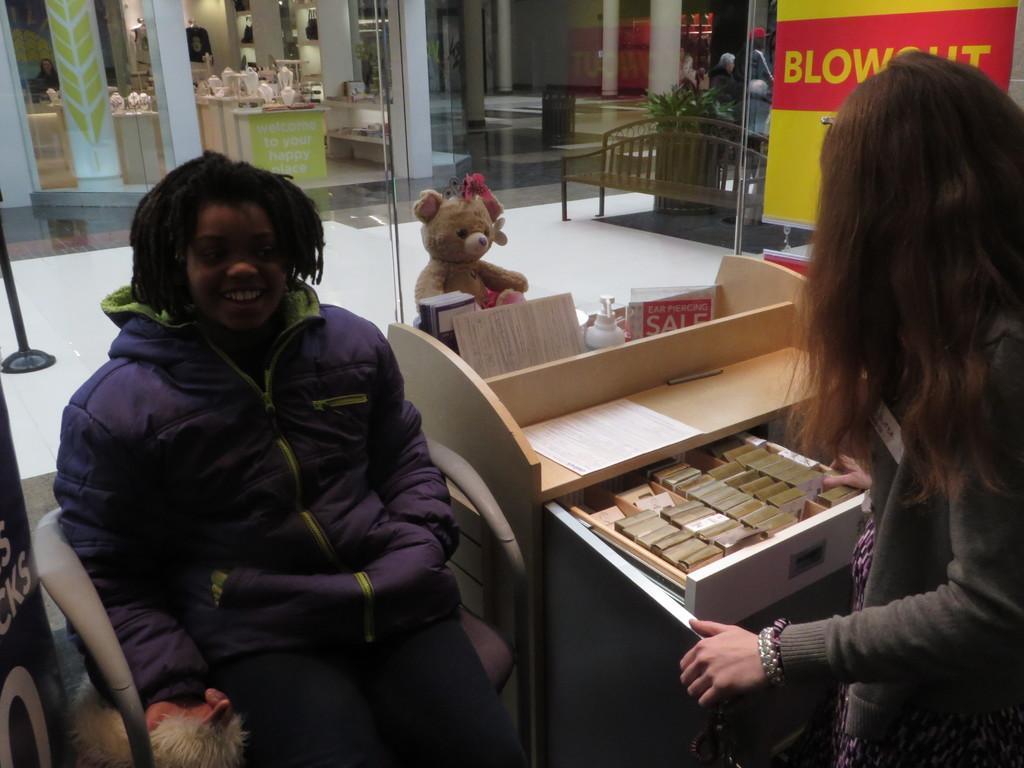Could you give a brief overview of what you see in this image? this picture shows a woman seated with a smile on her face and we see a woman standing 